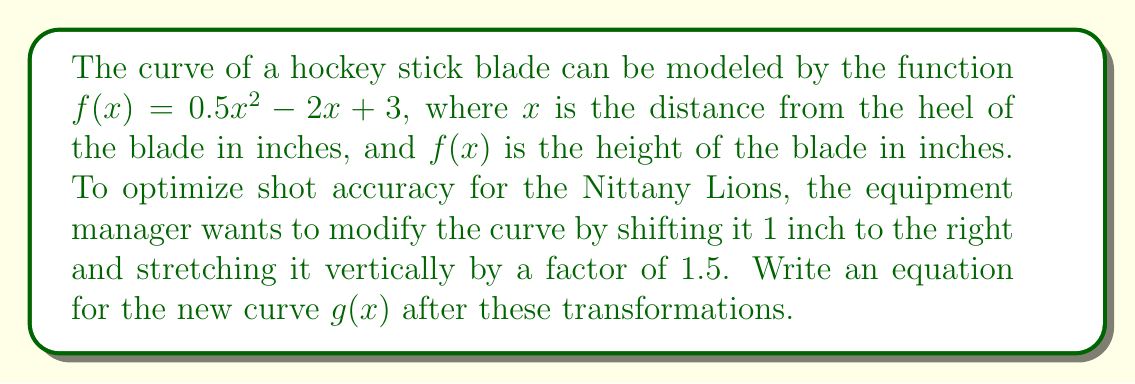Can you solve this math problem? To solve this problem, we'll apply the transformations step-by-step:

1. Start with the original function: $f(x) = 0.5x^2 - 2x + 3$

2. Shift 1 inch to the right:
   This transformation is represented by replacing $x$ with $(x - 1)$
   $f(x - 1) = 0.5(x - 1)^2 - 2(x - 1) + 3$

3. Stretch vertically by a factor of 1.5:
   Multiply the entire function by 1.5
   $g(x) = 1.5[0.5(x - 1)^2 - 2(x - 1) + 3]$

4. Expand the equation:
   $g(x) = 1.5[0.5(x^2 - 2x + 1) - 2x + 2 + 3]$
   $g(x) = 1.5[0.5x^2 - x + 0.5 - 2x + 5]$
   $g(x) = 1.5(0.5x^2 - 3x + 5.5)$

5. Simplify:
   $g(x) = 0.75x^2 - 4.5x + 8.25$

Therefore, the equation for the new curve after the transformations is $g(x) = 0.75x^2 - 4.5x + 8.25$.
Answer: $g(x) = 0.75x^2 - 4.5x + 8.25$ 